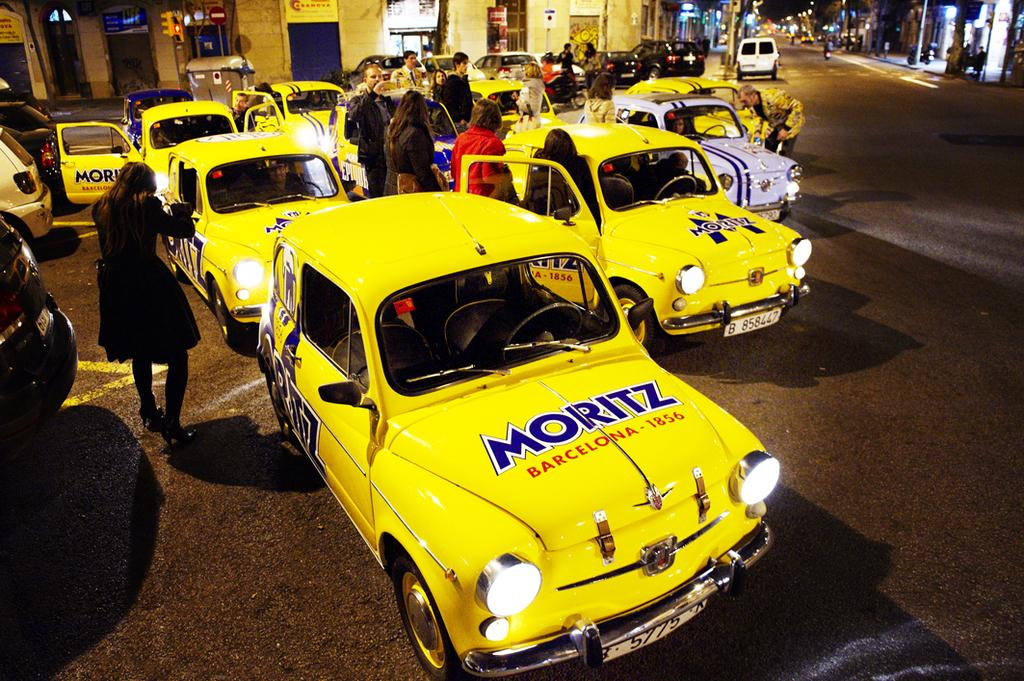<image>
Give a short and clear explanation of the subsequent image. a yellow car that has the name Moritz on it 